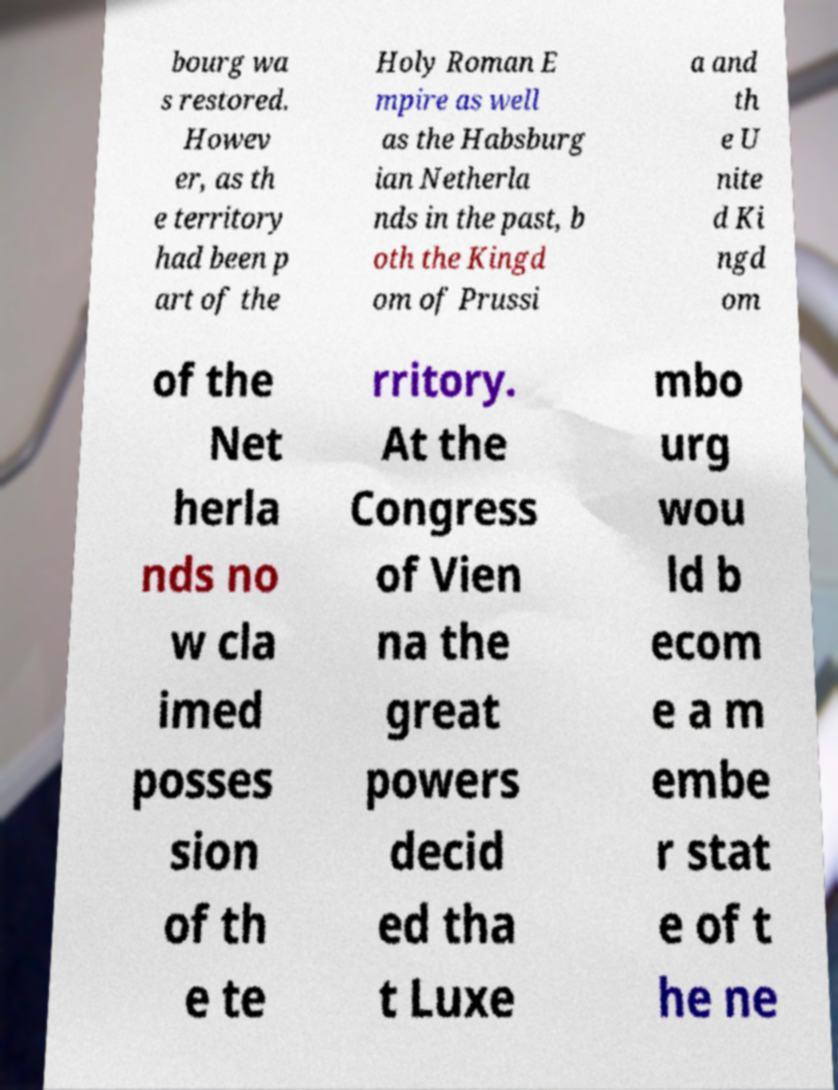Please identify and transcribe the text found in this image. bourg wa s restored. Howev er, as th e territory had been p art of the Holy Roman E mpire as well as the Habsburg ian Netherla nds in the past, b oth the Kingd om of Prussi a and th e U nite d Ki ngd om of the Net herla nds no w cla imed posses sion of th e te rritory. At the Congress of Vien na the great powers decid ed tha t Luxe mbo urg wou ld b ecom e a m embe r stat e of t he ne 